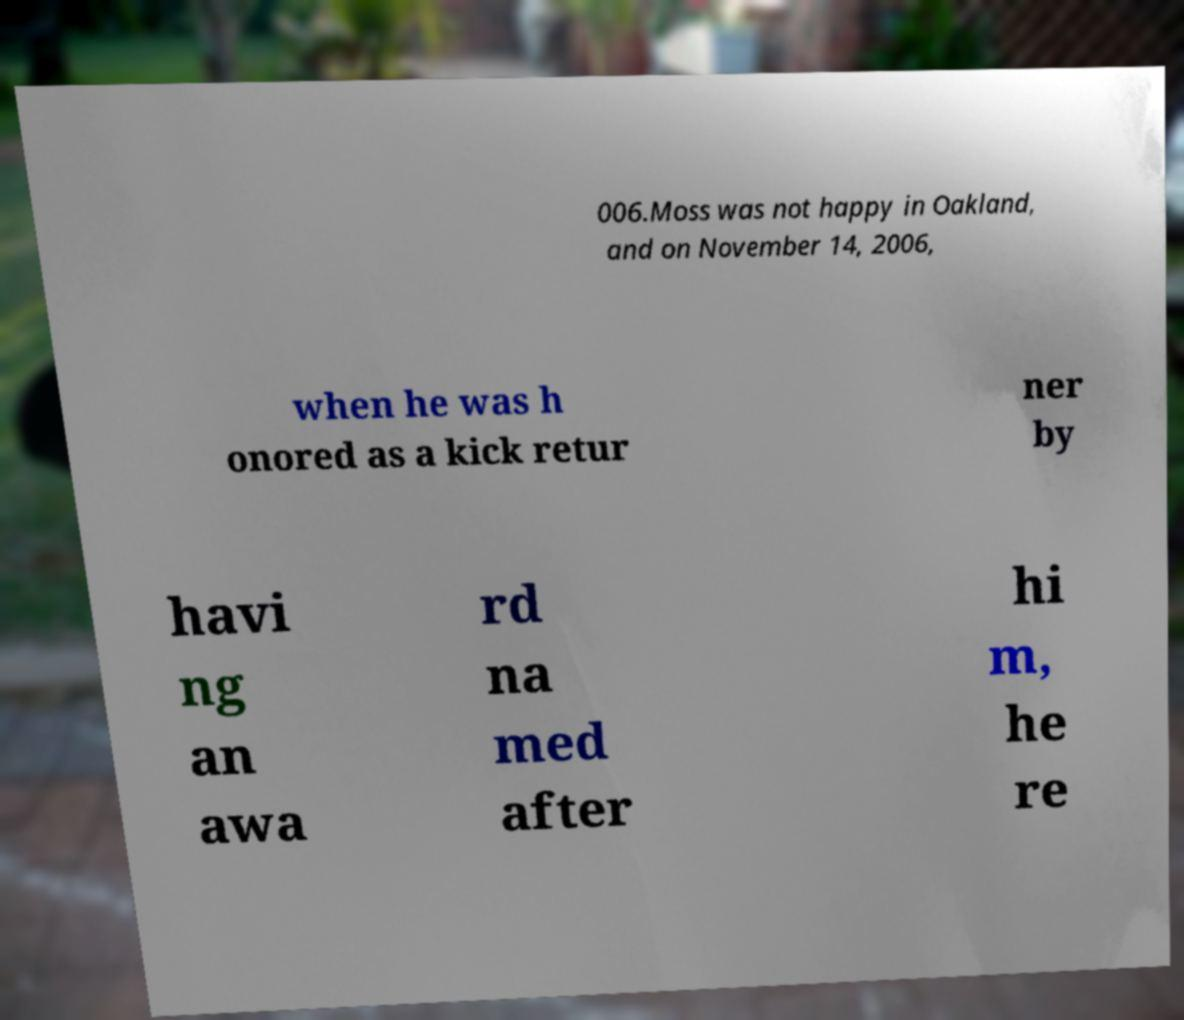Please read and relay the text visible in this image. What does it say? 006.Moss was not happy in Oakland, and on November 14, 2006, when he was h onored as a kick retur ner by havi ng an awa rd na med after hi m, he re 